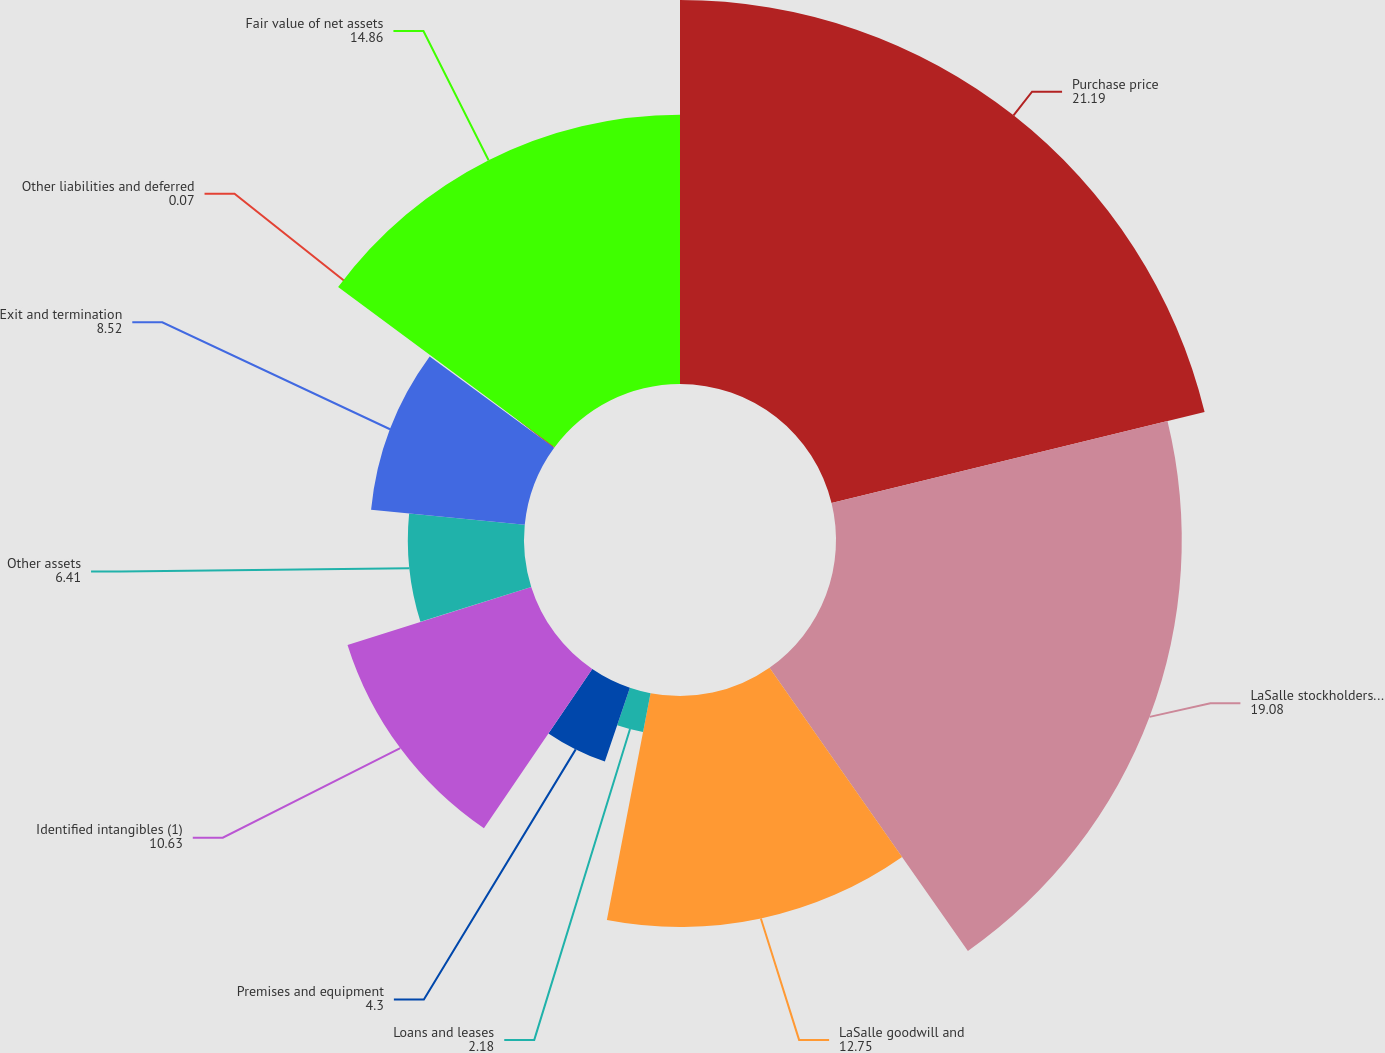Convert chart. <chart><loc_0><loc_0><loc_500><loc_500><pie_chart><fcel>Purchase price<fcel>LaSalle stockholders' equity<fcel>LaSalle goodwill and<fcel>Loans and leases<fcel>Premises and equipment<fcel>Identified intangibles (1)<fcel>Other assets<fcel>Exit and termination<fcel>Other liabilities and deferred<fcel>Fair value of net assets<nl><fcel>21.19%<fcel>19.08%<fcel>12.75%<fcel>2.18%<fcel>4.3%<fcel>10.63%<fcel>6.41%<fcel>8.52%<fcel>0.07%<fcel>14.86%<nl></chart> 